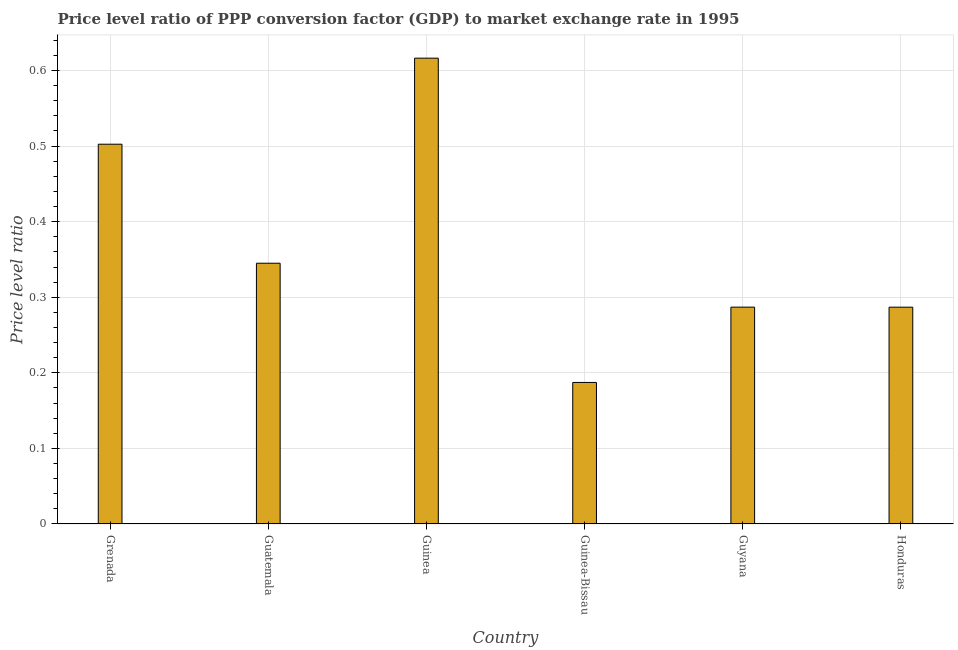Does the graph contain any zero values?
Give a very brief answer. No. What is the title of the graph?
Make the answer very short. Price level ratio of PPP conversion factor (GDP) to market exchange rate in 1995. What is the label or title of the X-axis?
Offer a terse response. Country. What is the label or title of the Y-axis?
Make the answer very short. Price level ratio. What is the price level ratio in Guatemala?
Ensure brevity in your answer.  0.35. Across all countries, what is the maximum price level ratio?
Your answer should be very brief. 0.62. Across all countries, what is the minimum price level ratio?
Provide a succinct answer. 0.19. In which country was the price level ratio maximum?
Provide a succinct answer. Guinea. In which country was the price level ratio minimum?
Make the answer very short. Guinea-Bissau. What is the sum of the price level ratio?
Offer a very short reply. 2.22. What is the difference between the price level ratio in Guinea and Guyana?
Give a very brief answer. 0.33. What is the average price level ratio per country?
Ensure brevity in your answer.  0.37. What is the median price level ratio?
Ensure brevity in your answer.  0.32. What is the ratio of the price level ratio in Grenada to that in Guatemala?
Ensure brevity in your answer.  1.46. What is the difference between the highest and the second highest price level ratio?
Your answer should be compact. 0.11. What is the difference between the highest and the lowest price level ratio?
Offer a terse response. 0.43. How many bars are there?
Give a very brief answer. 6. Are all the bars in the graph horizontal?
Your answer should be compact. No. What is the difference between two consecutive major ticks on the Y-axis?
Your answer should be compact. 0.1. Are the values on the major ticks of Y-axis written in scientific E-notation?
Provide a short and direct response. No. What is the Price level ratio of Grenada?
Keep it short and to the point. 0.5. What is the Price level ratio of Guatemala?
Offer a very short reply. 0.35. What is the Price level ratio in Guinea?
Provide a succinct answer. 0.62. What is the Price level ratio in Guinea-Bissau?
Your answer should be compact. 0.19. What is the Price level ratio in Guyana?
Provide a short and direct response. 0.29. What is the Price level ratio of Honduras?
Offer a terse response. 0.29. What is the difference between the Price level ratio in Grenada and Guatemala?
Make the answer very short. 0.16. What is the difference between the Price level ratio in Grenada and Guinea?
Ensure brevity in your answer.  -0.11. What is the difference between the Price level ratio in Grenada and Guinea-Bissau?
Provide a succinct answer. 0.32. What is the difference between the Price level ratio in Grenada and Guyana?
Ensure brevity in your answer.  0.22. What is the difference between the Price level ratio in Grenada and Honduras?
Offer a terse response. 0.22. What is the difference between the Price level ratio in Guatemala and Guinea?
Provide a succinct answer. -0.27. What is the difference between the Price level ratio in Guatemala and Guinea-Bissau?
Keep it short and to the point. 0.16. What is the difference between the Price level ratio in Guatemala and Guyana?
Ensure brevity in your answer.  0.06. What is the difference between the Price level ratio in Guatemala and Honduras?
Provide a succinct answer. 0.06. What is the difference between the Price level ratio in Guinea and Guinea-Bissau?
Your answer should be compact. 0.43. What is the difference between the Price level ratio in Guinea and Guyana?
Make the answer very short. 0.33. What is the difference between the Price level ratio in Guinea and Honduras?
Ensure brevity in your answer.  0.33. What is the difference between the Price level ratio in Guinea-Bissau and Guyana?
Your response must be concise. -0.1. What is the difference between the Price level ratio in Guinea-Bissau and Honduras?
Ensure brevity in your answer.  -0.1. What is the difference between the Price level ratio in Guyana and Honduras?
Make the answer very short. 6e-5. What is the ratio of the Price level ratio in Grenada to that in Guatemala?
Your answer should be very brief. 1.46. What is the ratio of the Price level ratio in Grenada to that in Guinea?
Give a very brief answer. 0.81. What is the ratio of the Price level ratio in Grenada to that in Guinea-Bissau?
Make the answer very short. 2.68. What is the ratio of the Price level ratio in Grenada to that in Guyana?
Offer a very short reply. 1.75. What is the ratio of the Price level ratio in Grenada to that in Honduras?
Provide a succinct answer. 1.75. What is the ratio of the Price level ratio in Guatemala to that in Guinea?
Keep it short and to the point. 0.56. What is the ratio of the Price level ratio in Guatemala to that in Guinea-Bissau?
Provide a succinct answer. 1.84. What is the ratio of the Price level ratio in Guatemala to that in Guyana?
Provide a short and direct response. 1.2. What is the ratio of the Price level ratio in Guatemala to that in Honduras?
Ensure brevity in your answer.  1.2. What is the ratio of the Price level ratio in Guinea to that in Guinea-Bissau?
Provide a succinct answer. 3.29. What is the ratio of the Price level ratio in Guinea to that in Guyana?
Your answer should be very brief. 2.15. What is the ratio of the Price level ratio in Guinea to that in Honduras?
Your response must be concise. 2.15. What is the ratio of the Price level ratio in Guinea-Bissau to that in Guyana?
Ensure brevity in your answer.  0.65. What is the ratio of the Price level ratio in Guinea-Bissau to that in Honduras?
Make the answer very short. 0.65. 